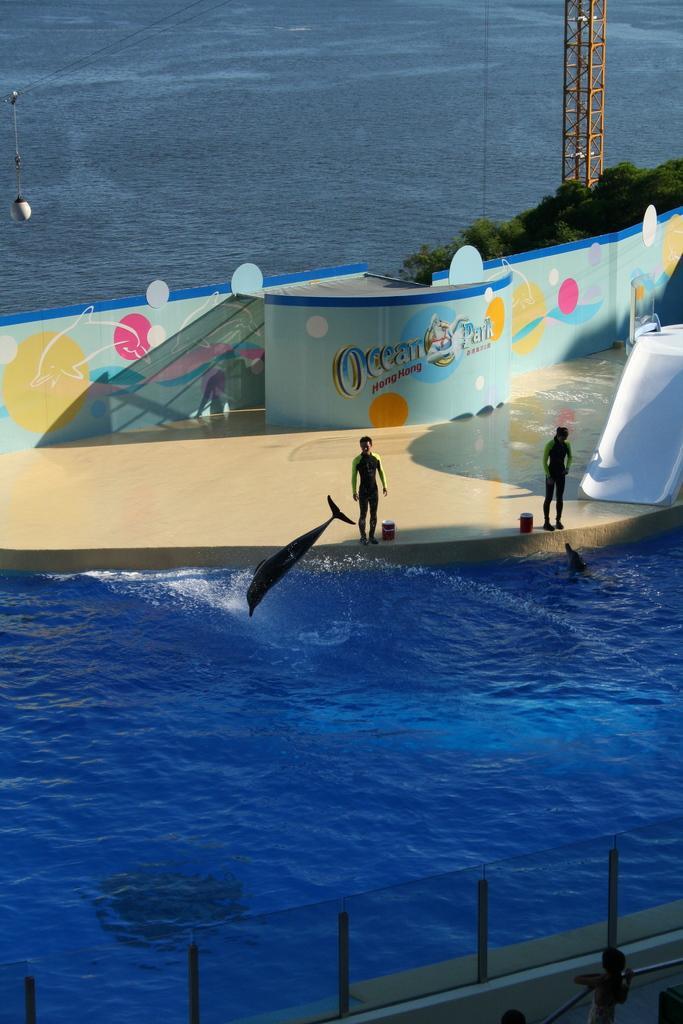Could you give a brief overview of what you see in this image? This is a freshwater river. Here we can able to see a swimming pool with dolphins. On this floor persons are standing. This wall is colorful. We can able to see trees and tower. 